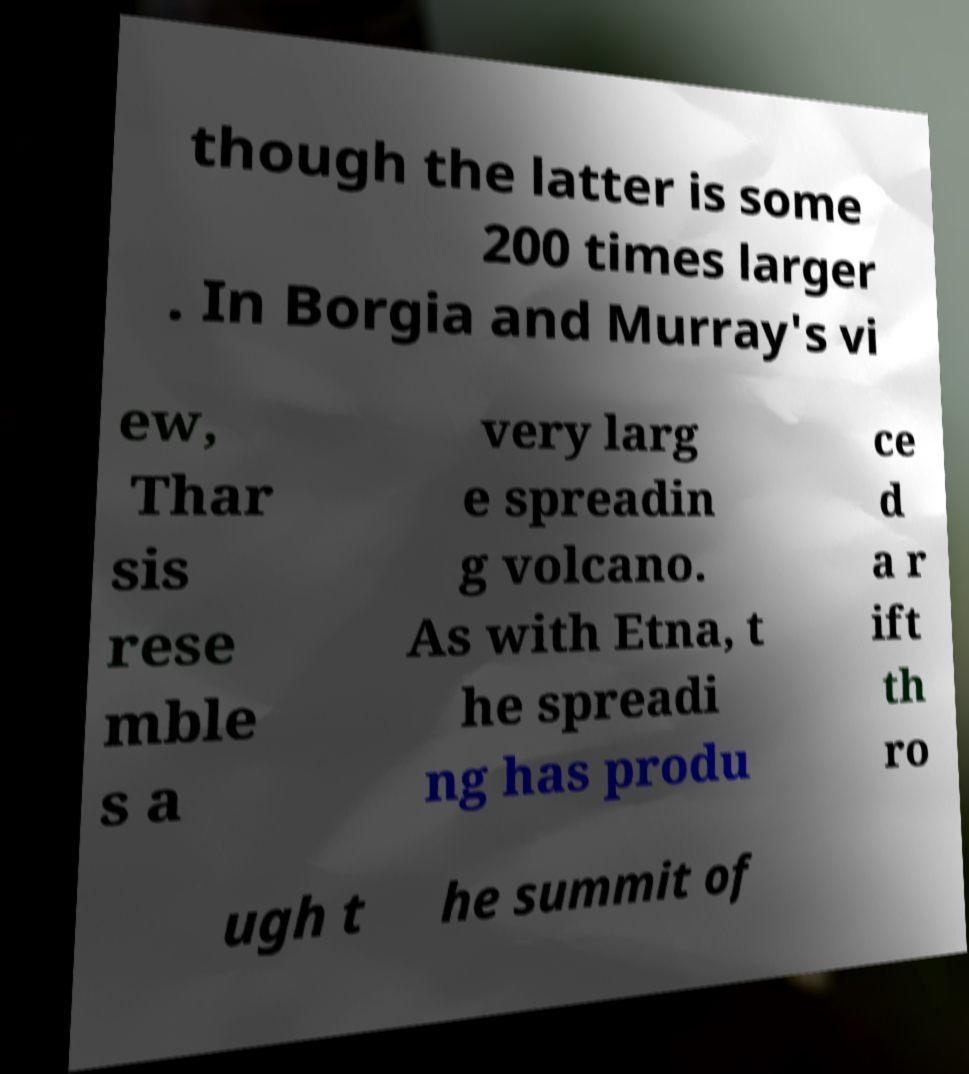Can you accurately transcribe the text from the provided image for me? though the latter is some 200 times larger . In Borgia and Murray's vi ew, Thar sis rese mble s a very larg e spreadin g volcano. As with Etna, t he spreadi ng has produ ce d a r ift th ro ugh t he summit of 